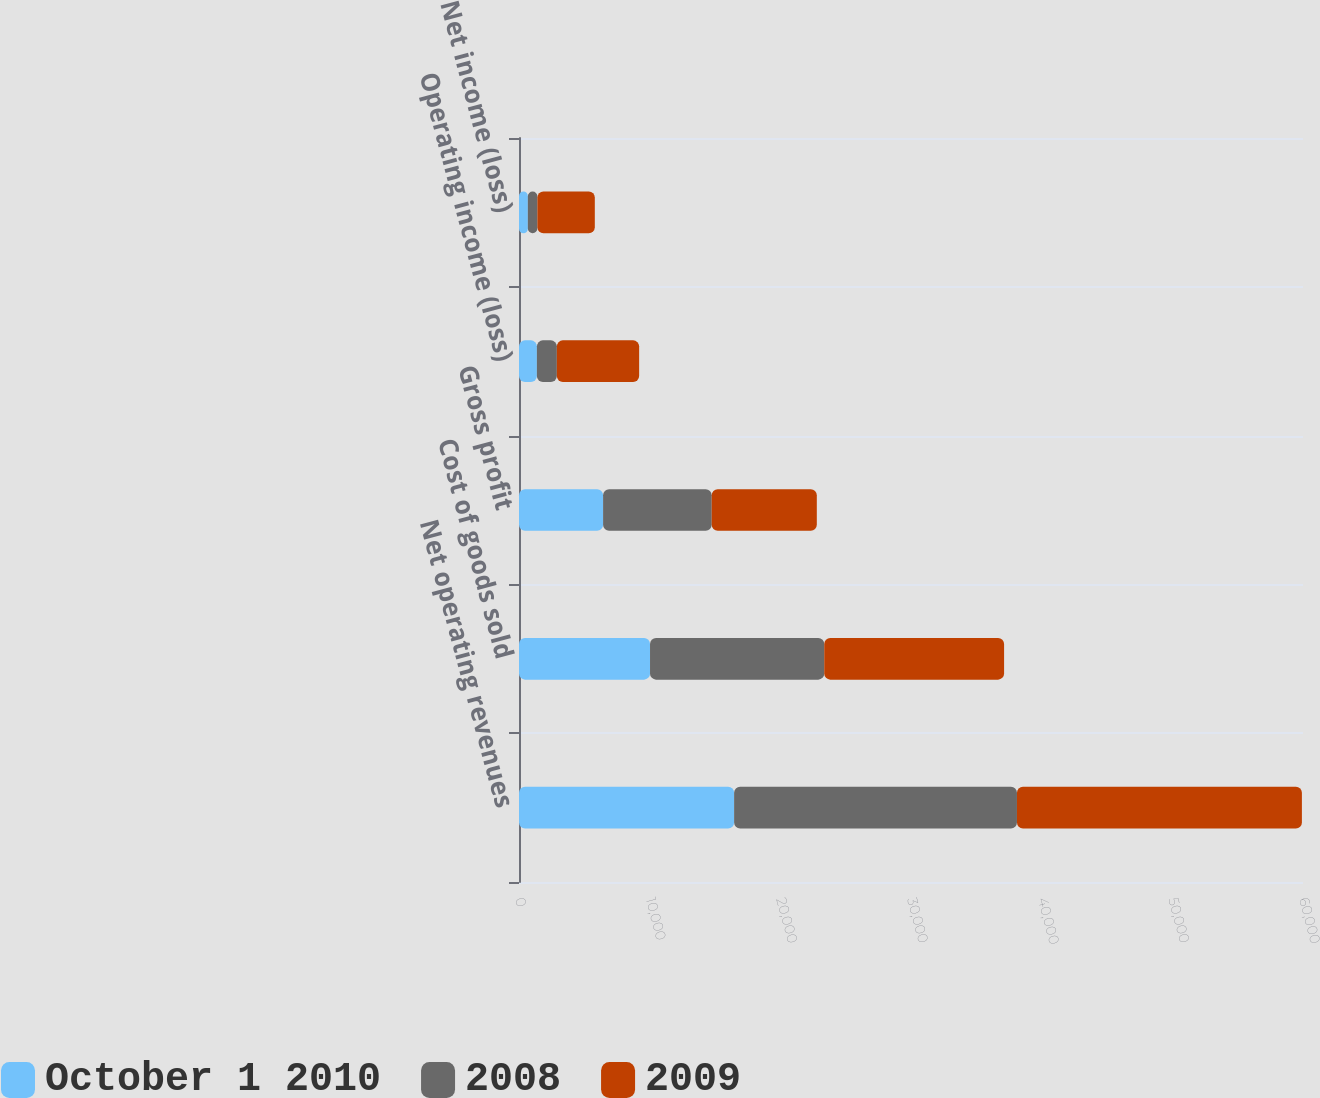<chart> <loc_0><loc_0><loc_500><loc_500><stacked_bar_chart><ecel><fcel>Net operating revenues<fcel>Cost of goods sold<fcel>Gross profit<fcel>Operating income (loss)<fcel>Net income (loss)<nl><fcel>October 1 2010<fcel>16464<fcel>10028<fcel>6436<fcel>1369<fcel>677<nl><fcel>2008<fcel>21645<fcel>13333<fcel>8312<fcel>1527<fcel>731<nl><fcel>2009<fcel>21807<fcel>13763<fcel>8044<fcel>6299<fcel>4394<nl></chart> 